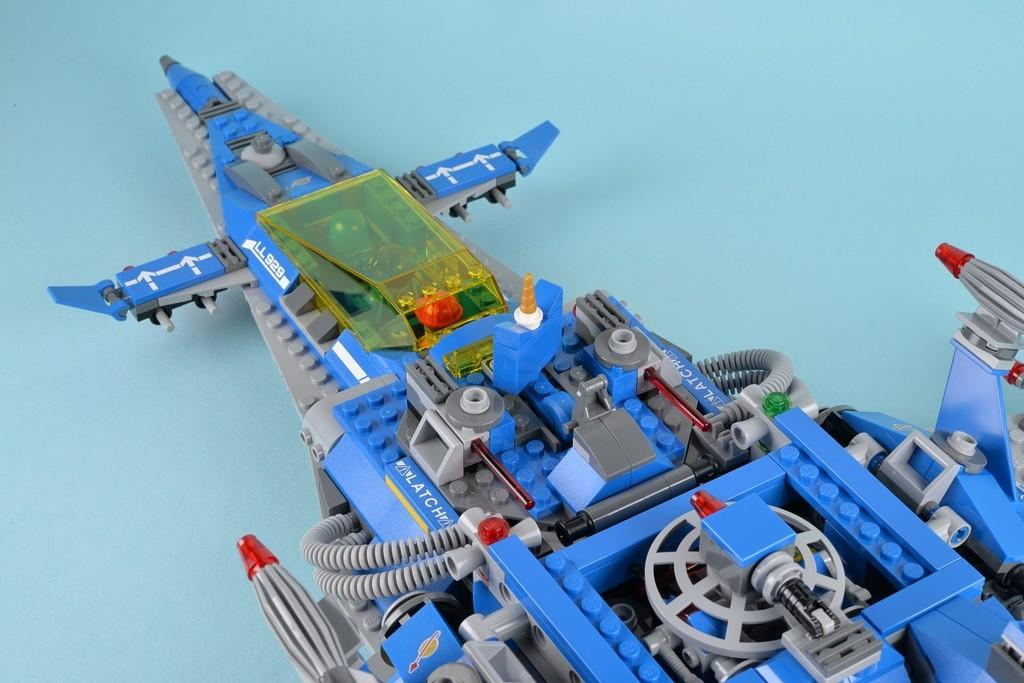What is the main object in the image? There is a toy plane in the image. Where is the toy plane located? The toy plane is on a surface. What color is the surface on which the toy plane is placed? The surface is light blue in color. How many horses can be seen running on the light blue surface in the image? There are no horses present in the image; it features a toy plane on a light blue surface. Who is the creator of the toy plane in the image? The image does not provide information about the creator of the toy plane. 